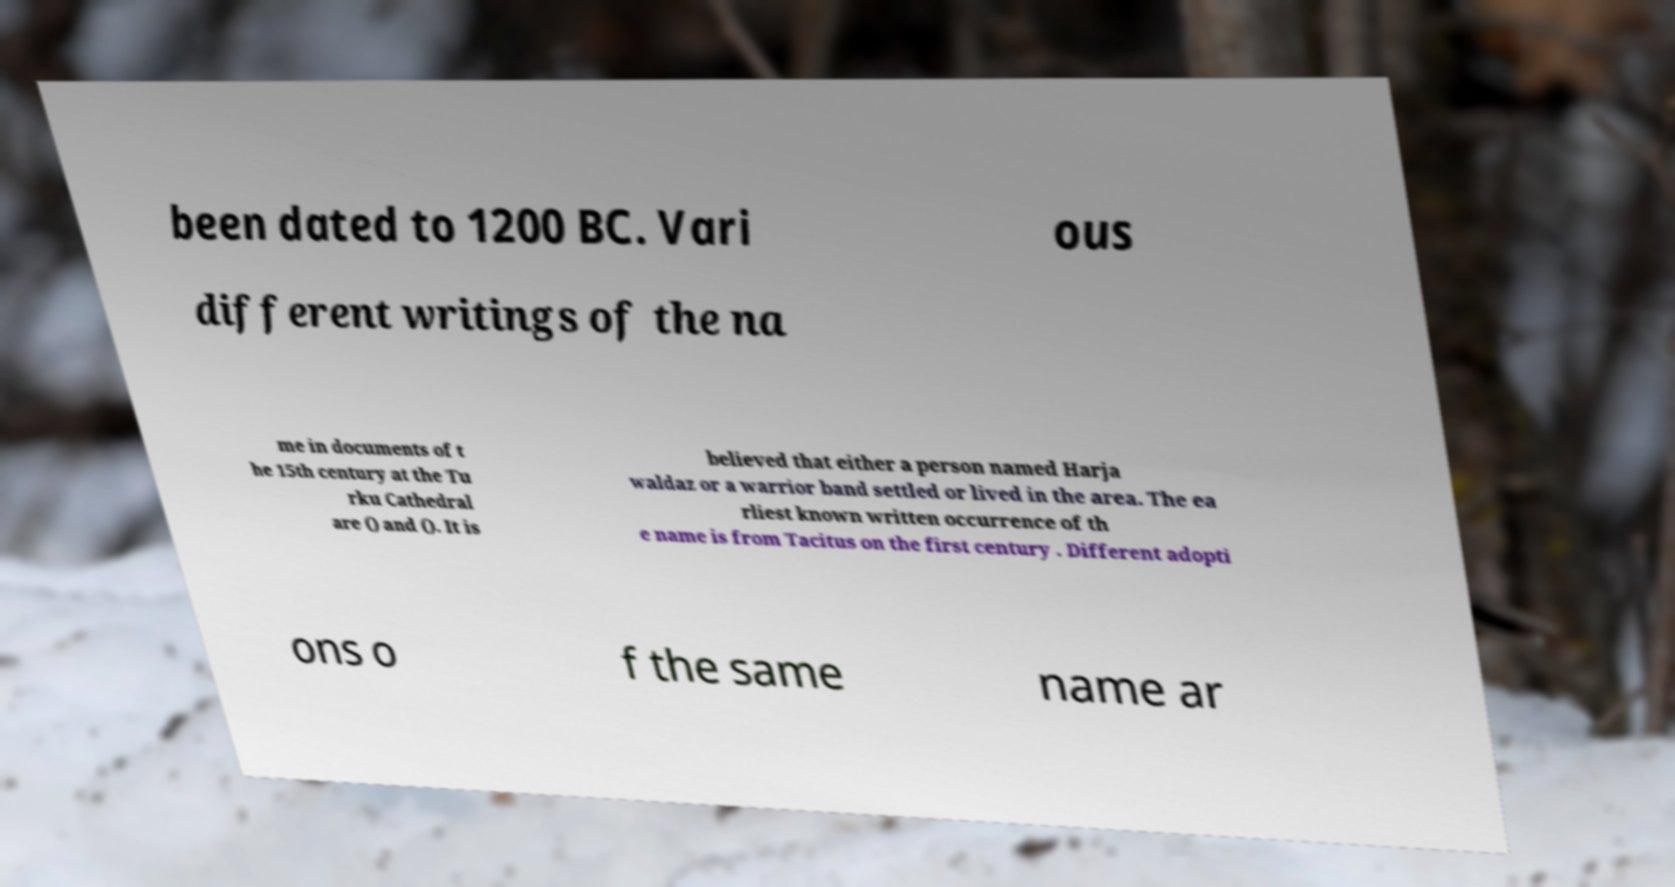I need the written content from this picture converted into text. Can you do that? been dated to 1200 BC. Vari ous different writings of the na me in documents of t he 15th century at the Tu rku Cathedral are () and (). It is believed that either a person named Harja waldaz or a warrior band settled or lived in the area. The ea rliest known written occurrence of th e name is from Tacitus on the first century . Different adopti ons o f the same name ar 